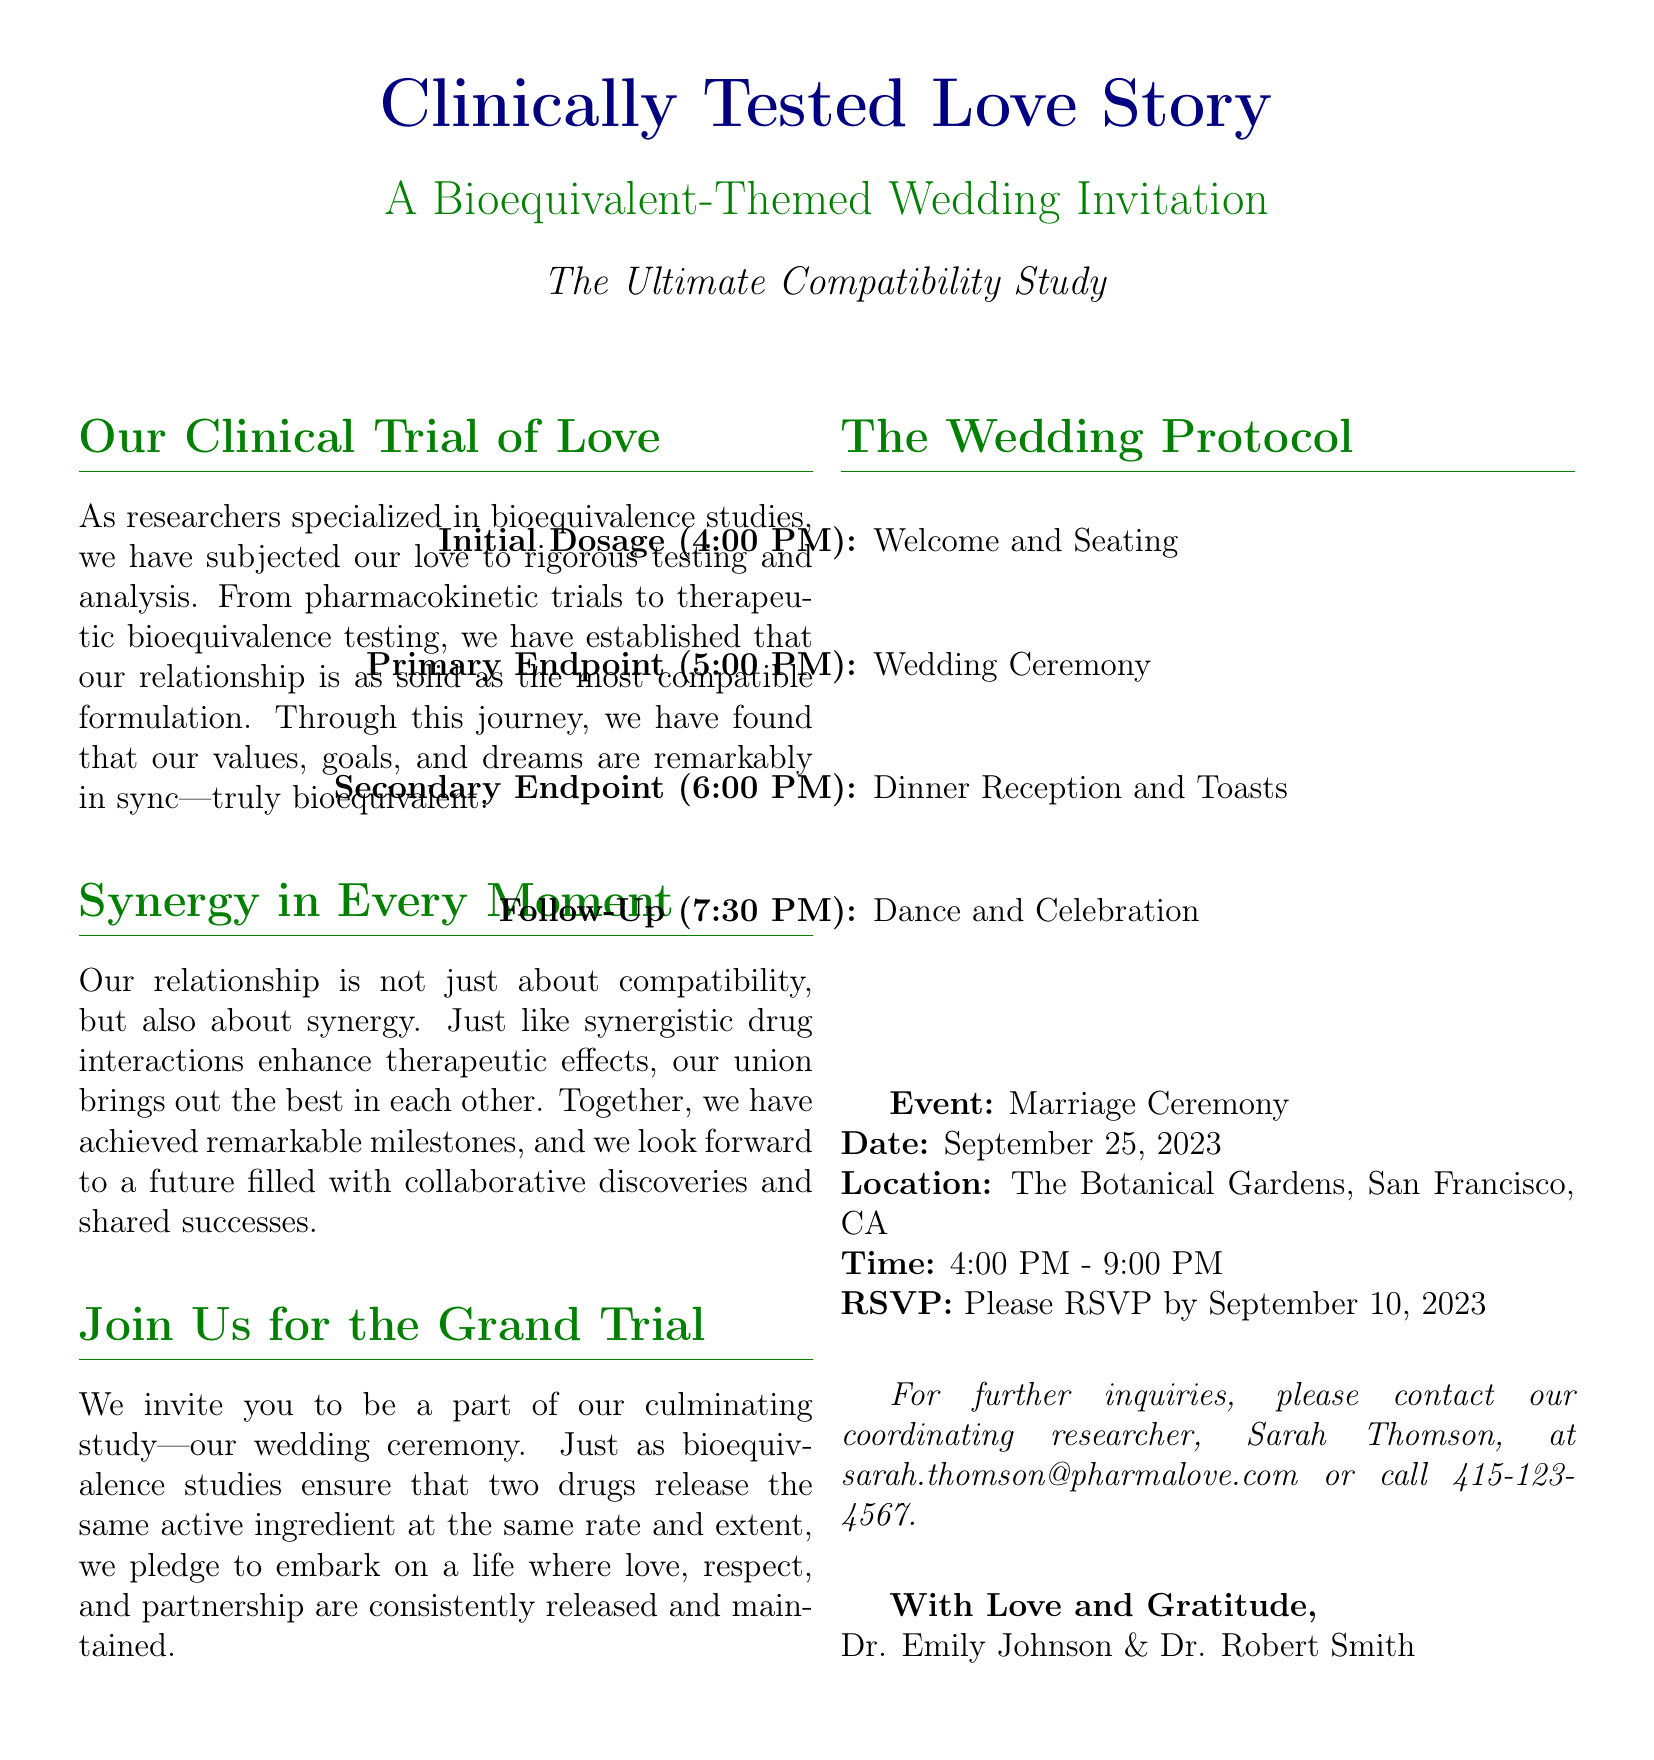What is the title of the invitation? The title is prominently displayed at the beginning of the document.
Answer: Clinically Tested Love Story What date is the wedding ceremony scheduled for? The date of the wedding is explicitly stated in the document.
Answer: September 25, 2023 Where is the wedding located? The location of the marriage ceremony is mentioned clearly in the document.
Answer: The Botanical Gardens, San Francisco, CA What time does the welcome and seating begin? The initial dosage or welcome time is part of the wedding protocol outlined in the document.
Answer: 4:00 PM What is the role of Sarah Thomson in the invitation? The role of Sarah Thomson is specified in the contact section at the end of the document.
Answer: Coordinating researcher What theme is used for the wedding invitation? The theme is reflected in the title and the content of the invitation.
Answer: Bioequivalent What milestone does the couple look forward to in their future? The document mentions aspirations for the future that involves shared experiences.
Answer: Collaborative discoveries How can guests confirm their attendance? The RSVP section outlines how guests should respond regarding their attendance.
Answer: By September 10, 2023 What happens after the dinner reception according to the protocol? The follow-up event is stated in the wedding protocol section.
Answer: Dance and Celebration 